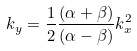<formula> <loc_0><loc_0><loc_500><loc_500>k _ { y } = \frac { 1 } { 2 } \frac { ( \alpha + \beta ) } { ( \alpha - \beta ) } k ^ { 2 } _ { x }</formula> 